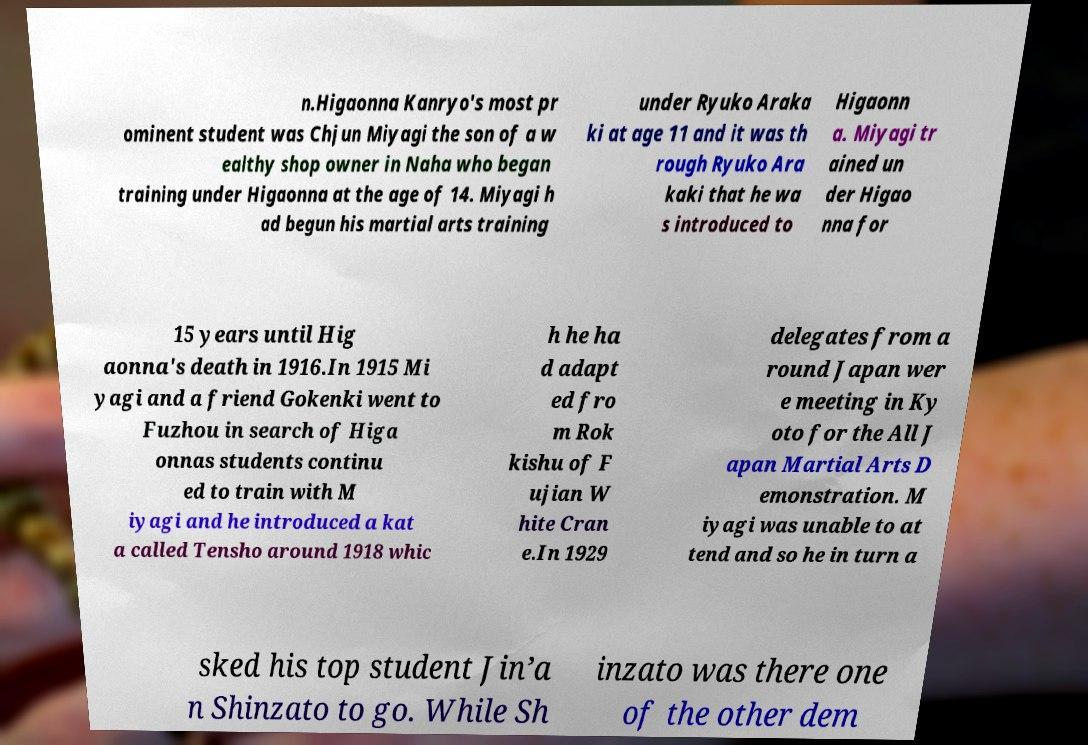Could you extract and type out the text from this image? n.Higaonna Kanryo's most pr ominent student was Chjun Miyagi the son of a w ealthy shop owner in Naha who began training under Higaonna at the age of 14. Miyagi h ad begun his martial arts training under Ryuko Araka ki at age 11 and it was th rough Ryuko Ara kaki that he wa s introduced to Higaonn a. Miyagi tr ained un der Higao nna for 15 years until Hig aonna's death in 1916.In 1915 Mi yagi and a friend Gokenki went to Fuzhou in search of Higa onnas students continu ed to train with M iyagi and he introduced a kat a called Tensho around 1918 whic h he ha d adapt ed fro m Rok kishu of F ujian W hite Cran e.In 1929 delegates from a round Japan wer e meeting in Ky oto for the All J apan Martial Arts D emonstration. M iyagi was unable to at tend and so he in turn a sked his top student Jin’a n Shinzato to go. While Sh inzato was there one of the other dem 